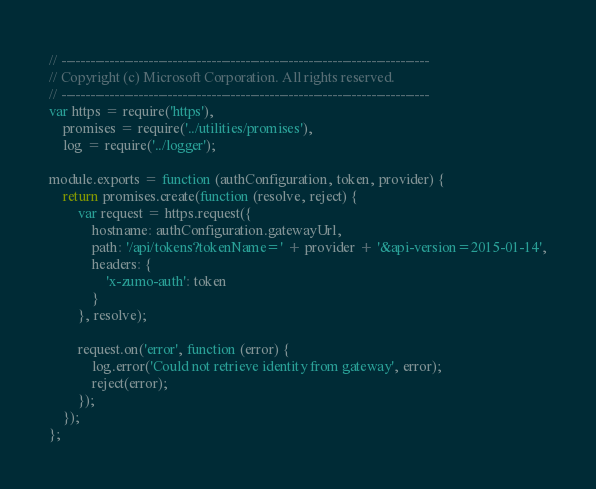<code> <loc_0><loc_0><loc_500><loc_500><_JavaScript_>// ----------------------------------------------------------------------------
// Copyright (c) Microsoft Corporation. All rights reserved.
// ----------------------------------------------------------------------------
var https = require('https'),
    promises = require('../utilities/promises'),
    log = require('../logger');

module.exports = function (authConfiguration, token, provider) {
    return promises.create(function (resolve, reject) {
        var request = https.request({
            hostname: authConfiguration.gatewayUrl,
            path: '/api/tokens?tokenName=' + provider + '&api-version=2015-01-14',
            headers: {
                'x-zumo-auth': token
            }
        }, resolve);

        request.on('error', function (error) {
            log.error('Could not retrieve identity from gateway', error);
            reject(error);
        });
    });
};
</code> 